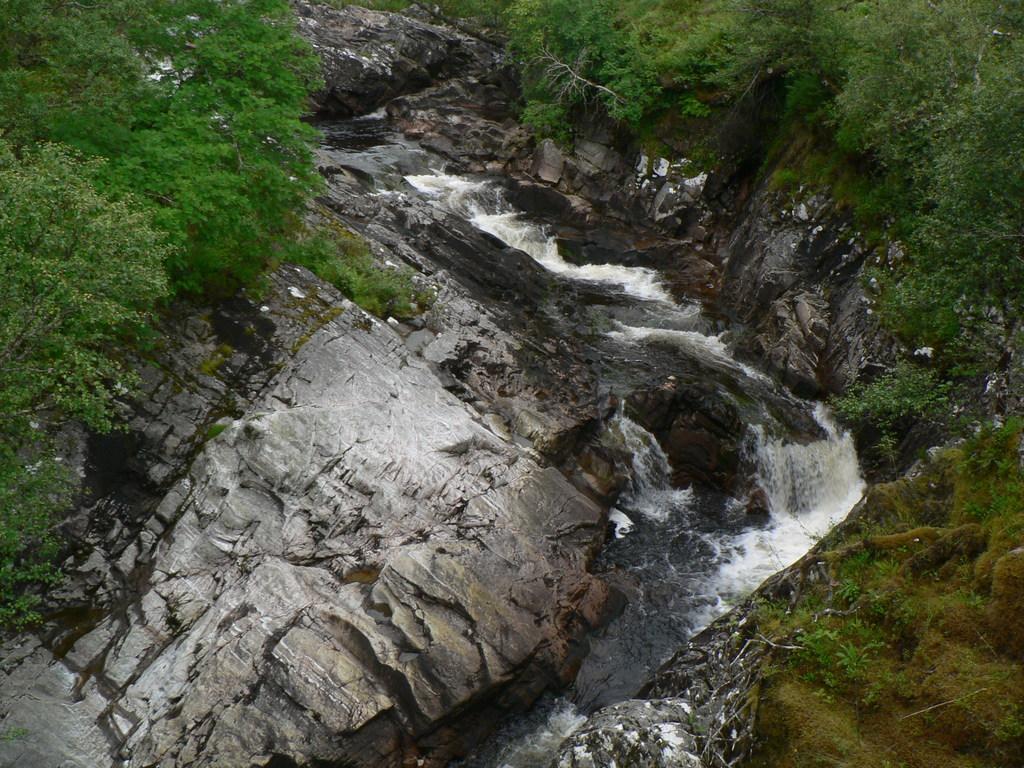Describe this image in one or two sentences. In this image I can see the hill and I can see grass visible on the hill and I can see water fountain visible on the lake 